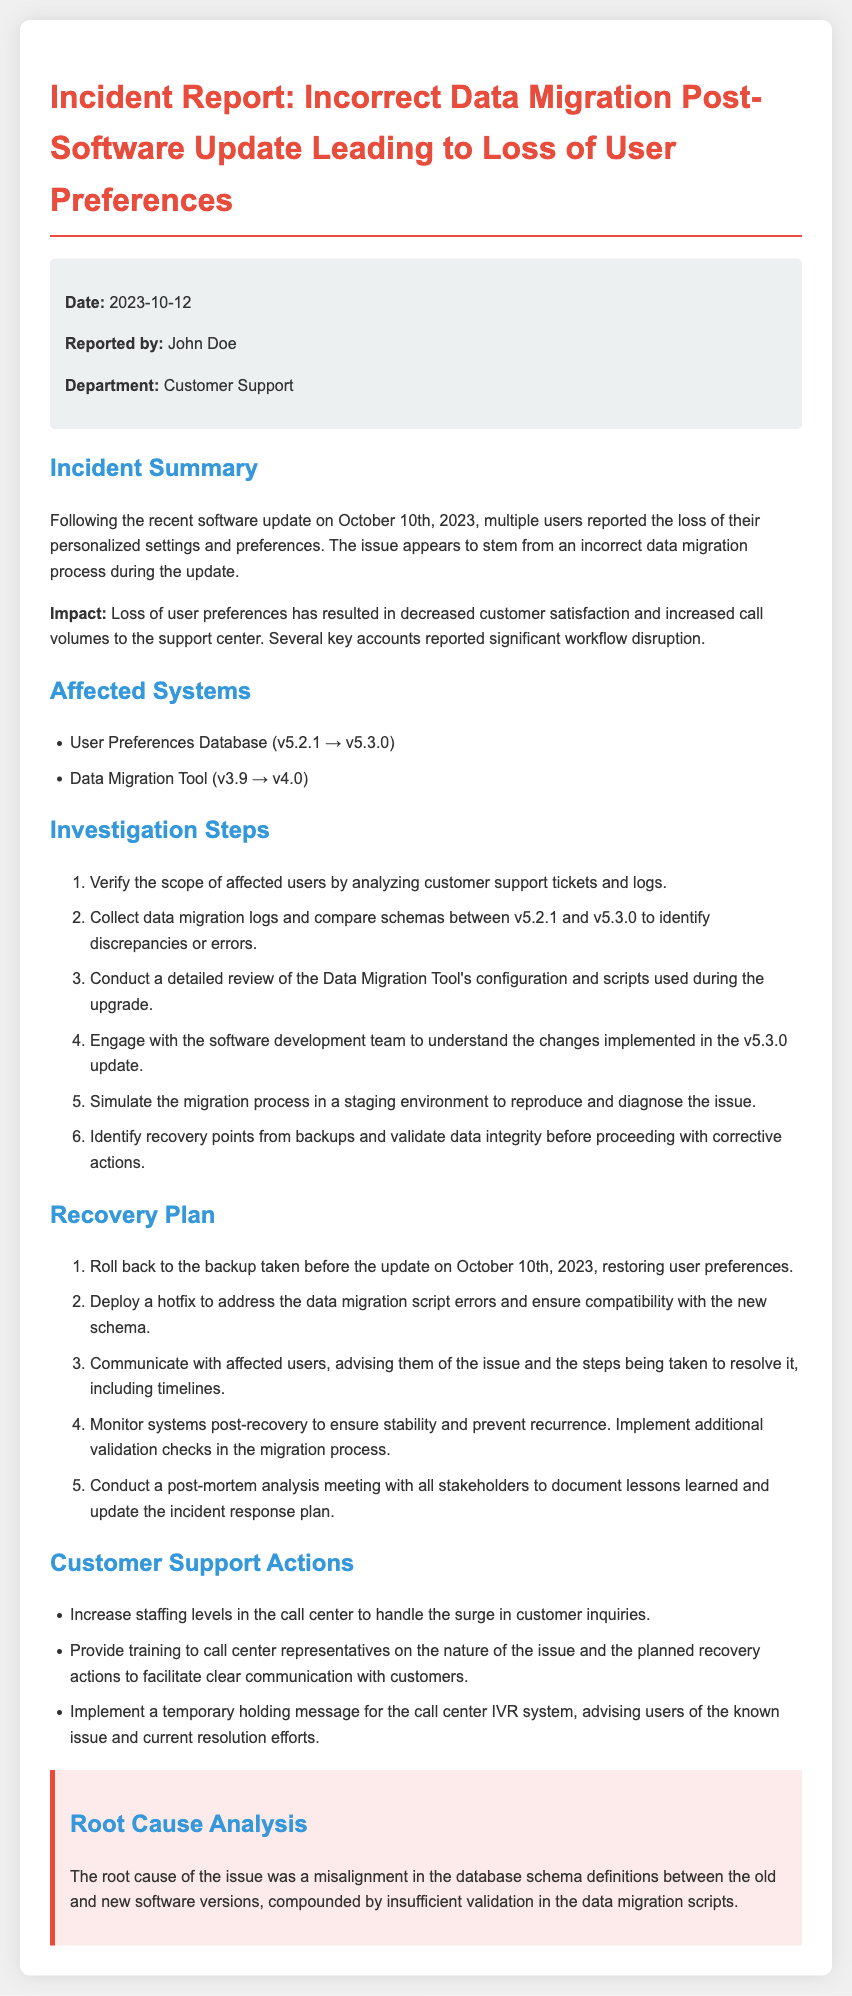what is the date of the incident report? The date of the incident report is stated in the meta-info section at the top of the document.
Answer: 2023-10-12 who reported the incident? The name of the person who reported the incident is also mentioned in the meta-info section.
Answer: John Doe what was the affected system's version in the data migration tool? The affected version of the data migration tool is listed under the affected systems section.
Answer: v4.0 how many investigation steps are outlined in the document? The number of investigation steps can be found by counting the items in the investigation steps section.
Answer: 6 what is the primary root cause of the issue? The root cause analysis summarizes the main cause found in the document.
Answer: Misalignment in the database schema definitions which user database version was affected by the incident? The affected user preferences database version is specified under the affected systems section.
Answer: v5.2.1 how many recovery actions are suggested in the recovery plan? The recovery actions can be counted in the recovery plan section of the document.
Answer: 5 what is one customer support action taken after the incident? The customer support actions are listed in that specific section of the document.
Answer: Increase staffing levels in the call center what was implemented to improve the migration process? The recovery plan includes actions aimed at improving future migrations and is described in the document.
Answer: Additional validation checks 